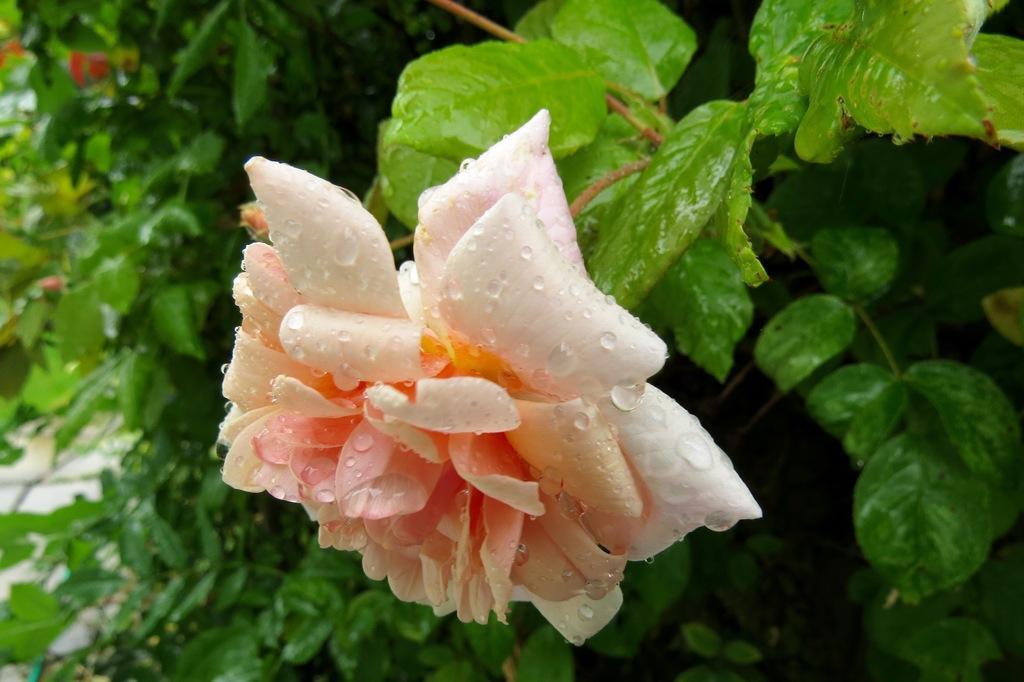Please provide a concise description of this image. In the middle of the image we can see a flower. Behind the flower we can see some plants. 